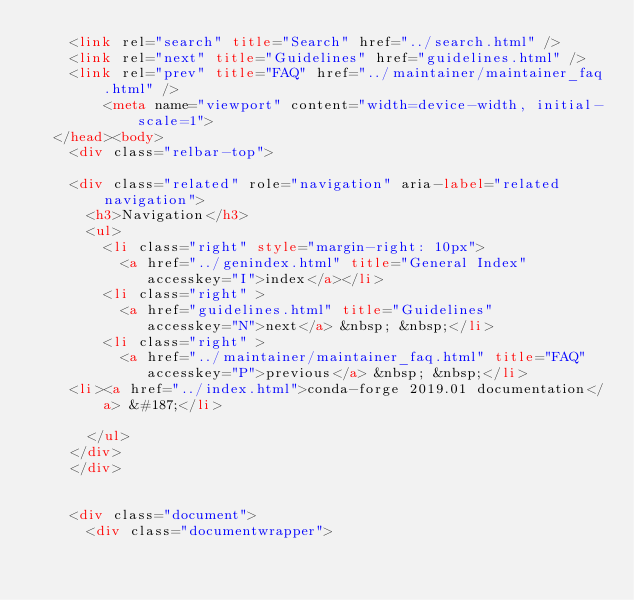Convert code to text. <code><loc_0><loc_0><loc_500><loc_500><_HTML_>    <link rel="search" title="Search" href="../search.html" />
    <link rel="next" title="Guidelines" href="guidelines.html" />
    <link rel="prev" title="FAQ" href="../maintainer/maintainer_faq.html" /> 
        <meta name="viewport" content="width=device-width, initial-scale=1">
  </head><body>
    <div class="relbar-top">
        
    <div class="related" role="navigation" aria-label="related navigation">
      <h3>Navigation</h3>
      <ul>
        <li class="right" style="margin-right: 10px">
          <a href="../genindex.html" title="General Index"
             accesskey="I">index</a></li>
        <li class="right" >
          <a href="guidelines.html" title="Guidelines"
             accesskey="N">next</a> &nbsp; &nbsp;</li>
        <li class="right" >
          <a href="../maintainer/maintainer_faq.html" title="FAQ"
             accesskey="P">previous</a> &nbsp; &nbsp;</li>
    <li><a href="../index.html">conda-forge 2019.01 documentation</a> &#187;</li>
 
      </ul>
    </div>
    </div>
  

    <div class="document">
      <div class="documentwrapper"></code> 